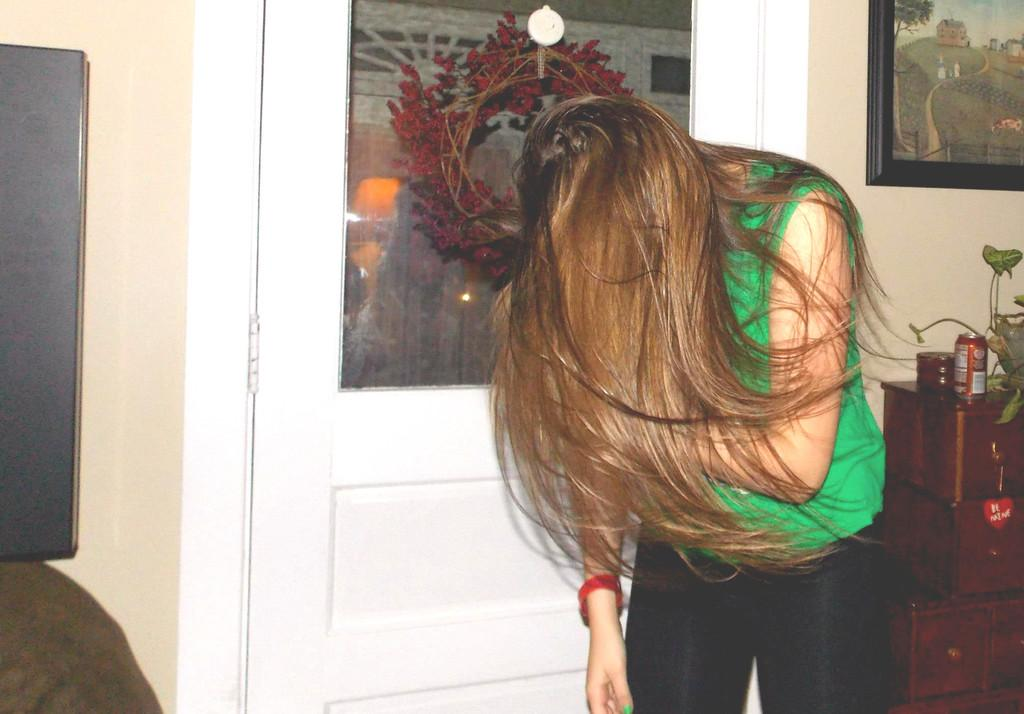Who is present in the image? There is a woman in the image. What can be seen in the background of the image? There is a wall, a photo frame, and a door in the background of the image. Where is the playground located in the image? There is no playground present in the image. How many bears are visible in the image? There are no bears present in the image. 